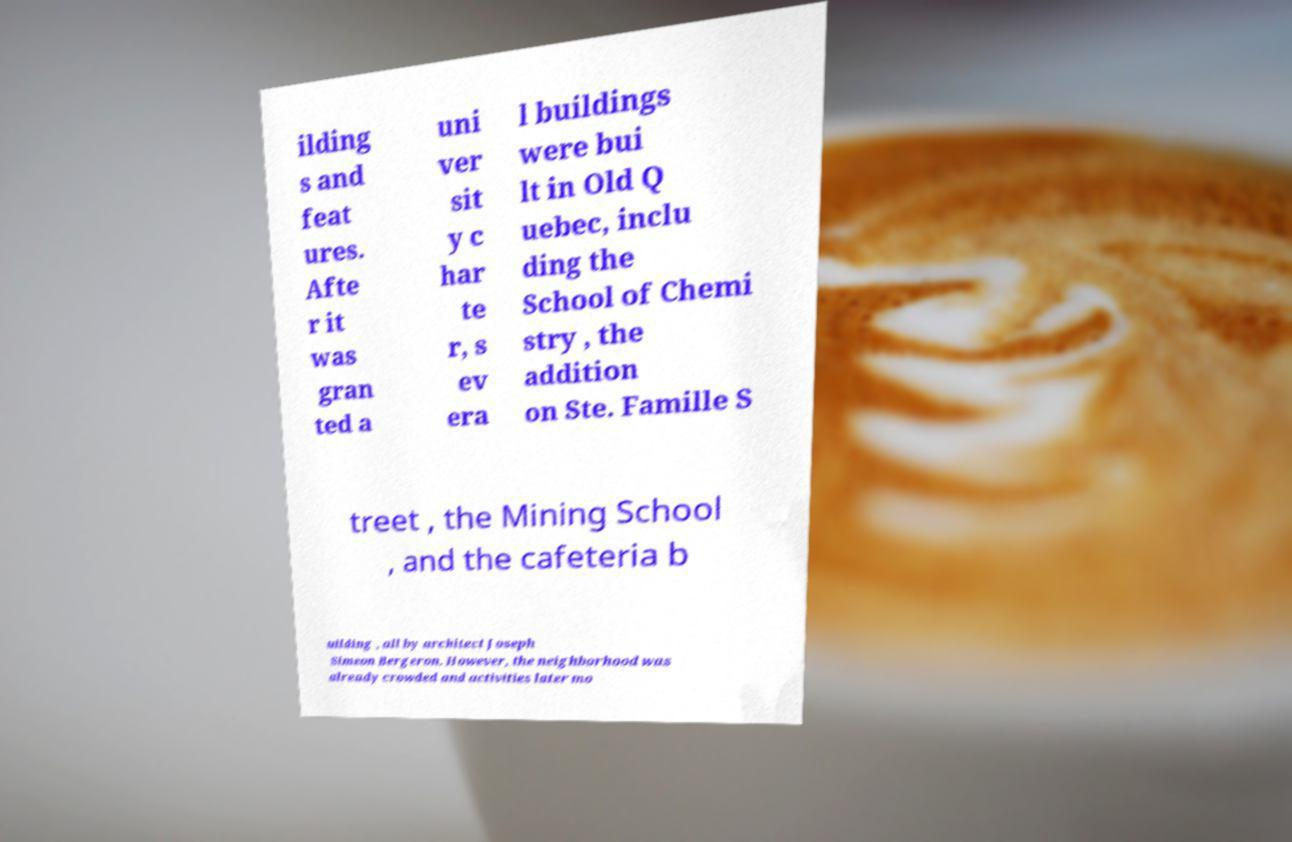There's text embedded in this image that I need extracted. Can you transcribe it verbatim? ilding s and feat ures. Afte r it was gran ted a uni ver sit y c har te r, s ev era l buildings were bui lt in Old Q uebec, inclu ding the School of Chemi stry , the addition on Ste. Famille S treet , the Mining School , and the cafeteria b uilding , all by architect Joseph Simeon Bergeron. However, the neighborhood was already crowded and activities later mo 